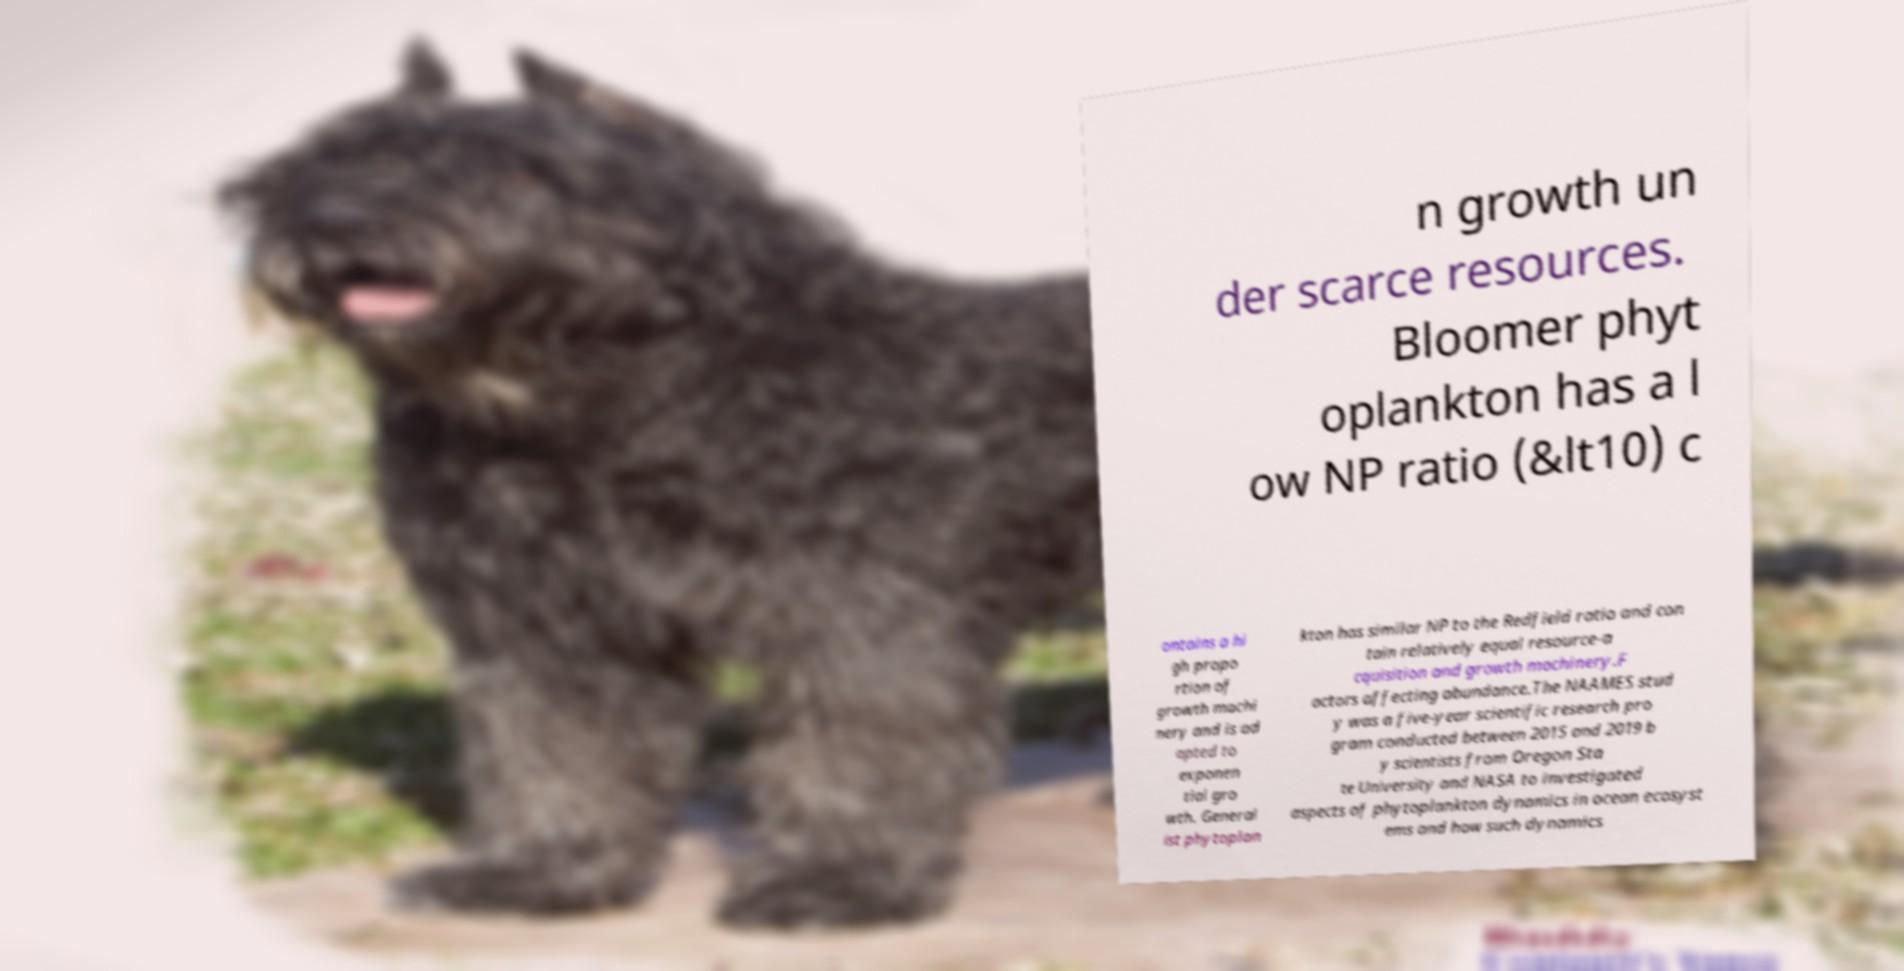Can you accurately transcribe the text from the provided image for me? n growth un der scarce resources. Bloomer phyt oplankton has a l ow NP ratio (&lt10) c ontains a hi gh propo rtion of growth machi nery and is ad apted to exponen tial gro wth. General ist phytoplan kton has similar NP to the Redfield ratio and con tain relatively equal resource-a cquisition and growth machinery.F actors affecting abundance.The NAAMES stud y was a five-year scientific research pro gram conducted between 2015 and 2019 b y scientists from Oregon Sta te University and NASA to investigated aspects of phytoplankton dynamics in ocean ecosyst ems and how such dynamics 